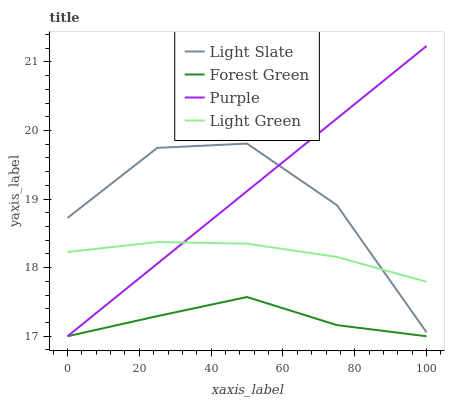Does Forest Green have the minimum area under the curve?
Answer yes or no. Yes. Does Purple have the maximum area under the curve?
Answer yes or no. Yes. Does Purple have the minimum area under the curve?
Answer yes or no. No. Does Forest Green have the maximum area under the curve?
Answer yes or no. No. Is Purple the smoothest?
Answer yes or no. Yes. Is Light Slate the roughest?
Answer yes or no. Yes. Is Forest Green the smoothest?
Answer yes or no. No. Is Forest Green the roughest?
Answer yes or no. No. Does Purple have the lowest value?
Answer yes or no. Yes. Does Light Green have the lowest value?
Answer yes or no. No. Does Purple have the highest value?
Answer yes or no. Yes. Does Forest Green have the highest value?
Answer yes or no. No. Is Forest Green less than Light Slate?
Answer yes or no. Yes. Is Light Green greater than Forest Green?
Answer yes or no. Yes. Does Purple intersect Forest Green?
Answer yes or no. Yes. Is Purple less than Forest Green?
Answer yes or no. No. Is Purple greater than Forest Green?
Answer yes or no. No. Does Forest Green intersect Light Slate?
Answer yes or no. No. 